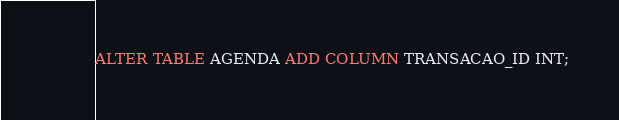Convert code to text. <code><loc_0><loc_0><loc_500><loc_500><_SQL_>ALTER TABLE AGENDA ADD COLUMN TRANSACAO_ID INT;</code> 